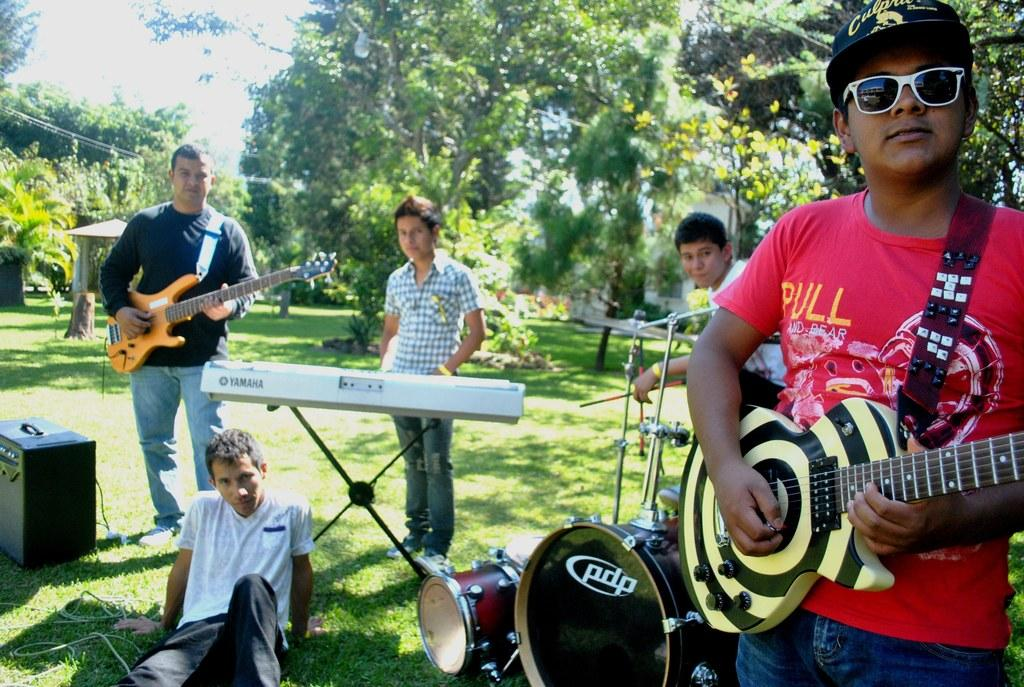How many people are in the image? There are five men in the image. What are the men doing in the image? The men are playing musical instruments. Where are the men sitting in the image? The men are sitting on the ground. What can be seen in the background of the image? There is a tree and the sky visible in the background of the image. What type of authority do the men have over the tree in the image? The men do not have any authority over the tree in the image, as they are playing musical instruments and sitting on the ground. 